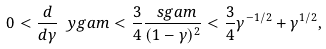Convert formula to latex. <formula><loc_0><loc_0><loc_500><loc_500>0 < \frac { d } { d \gamma } \ y g a m < \frac { 3 } { 4 } \frac { \ s g a m } { ( 1 - \gamma ) ^ { 2 } } < \frac { 3 } { 4 } \gamma ^ { - 1 / 2 } + \gamma ^ { 1 / 2 } ,</formula> 